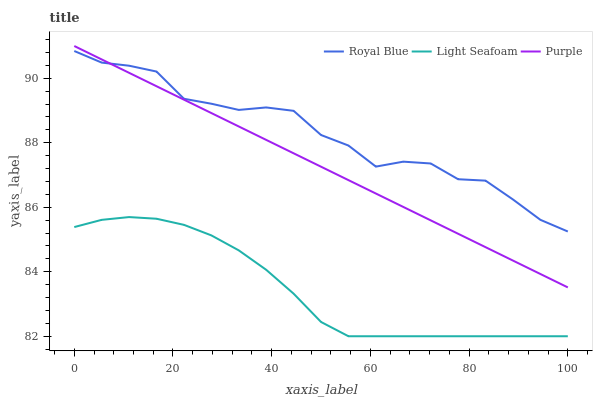Does Light Seafoam have the minimum area under the curve?
Answer yes or no. Yes. Does Royal Blue have the maximum area under the curve?
Answer yes or no. Yes. Does Royal Blue have the minimum area under the curve?
Answer yes or no. No. Does Light Seafoam have the maximum area under the curve?
Answer yes or no. No. Is Purple the smoothest?
Answer yes or no. Yes. Is Royal Blue the roughest?
Answer yes or no. Yes. Is Light Seafoam the smoothest?
Answer yes or no. No. Is Light Seafoam the roughest?
Answer yes or no. No. Does Light Seafoam have the lowest value?
Answer yes or no. Yes. Does Royal Blue have the lowest value?
Answer yes or no. No. Does Purple have the highest value?
Answer yes or no. Yes. Does Royal Blue have the highest value?
Answer yes or no. No. Is Light Seafoam less than Purple?
Answer yes or no. Yes. Is Royal Blue greater than Light Seafoam?
Answer yes or no. Yes. Does Purple intersect Royal Blue?
Answer yes or no. Yes. Is Purple less than Royal Blue?
Answer yes or no. No. Is Purple greater than Royal Blue?
Answer yes or no. No. Does Light Seafoam intersect Purple?
Answer yes or no. No. 